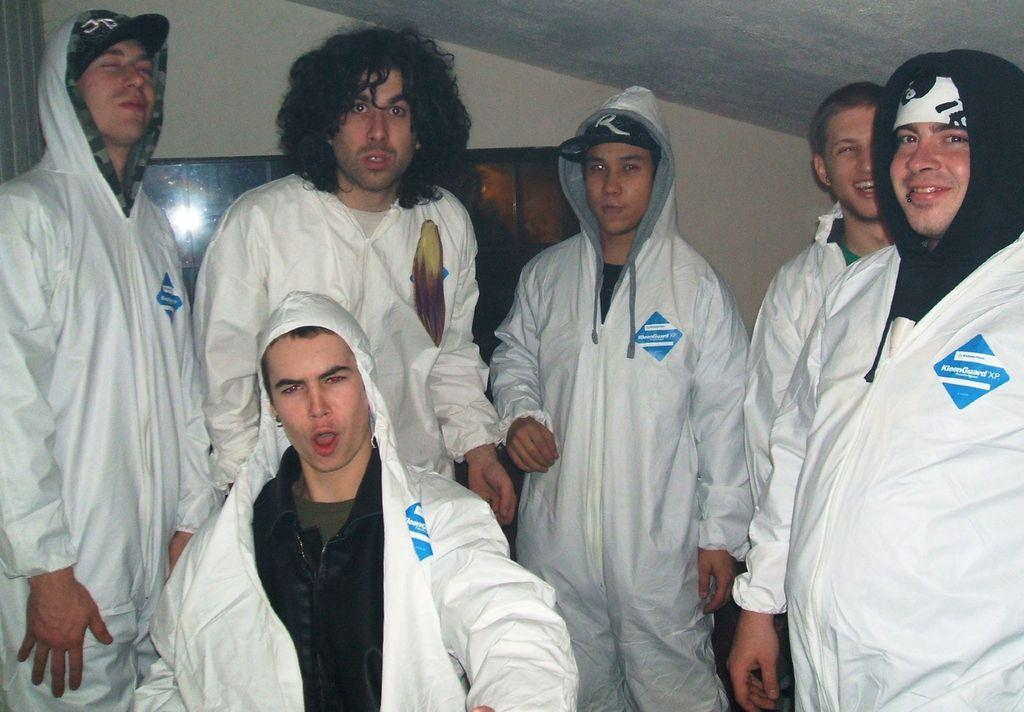Provide a one-sentence caption for the provided image. the word guard that is on a blue patch. 